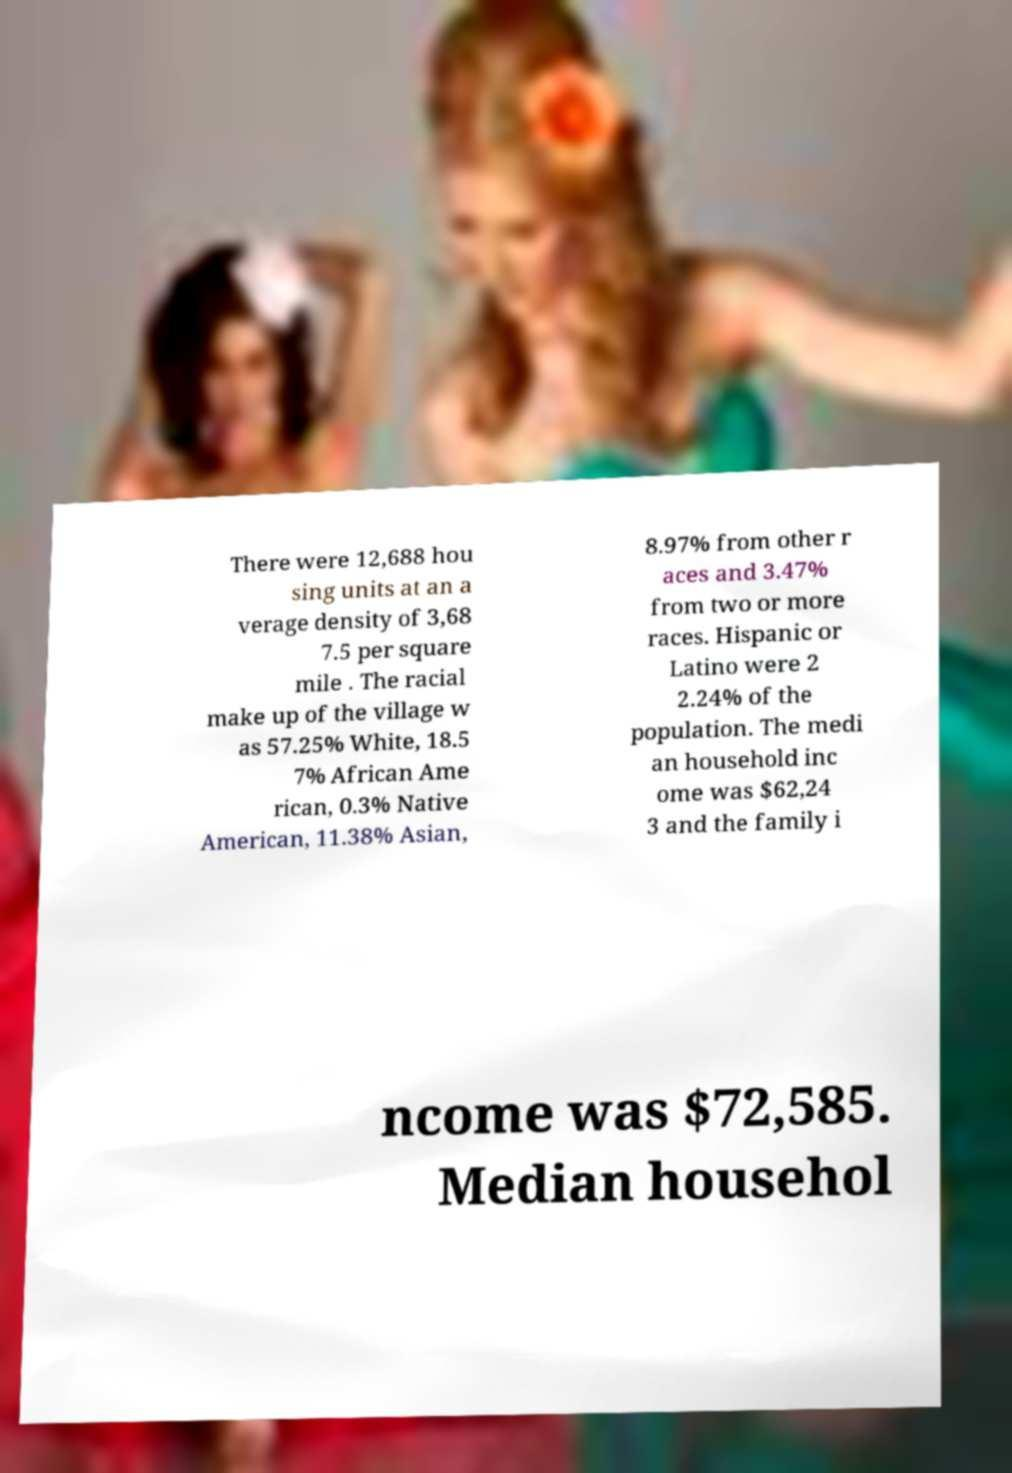What messages or text are displayed in this image? I need them in a readable, typed format. There were 12,688 hou sing units at an a verage density of 3,68 7.5 per square mile . The racial make up of the village w as 57.25% White, 18.5 7% African Ame rican, 0.3% Native American, 11.38% Asian, 8.97% from other r aces and 3.47% from two or more races. Hispanic or Latino were 2 2.24% of the population. The medi an household inc ome was $62,24 3 and the family i ncome was $72,585. Median househol 